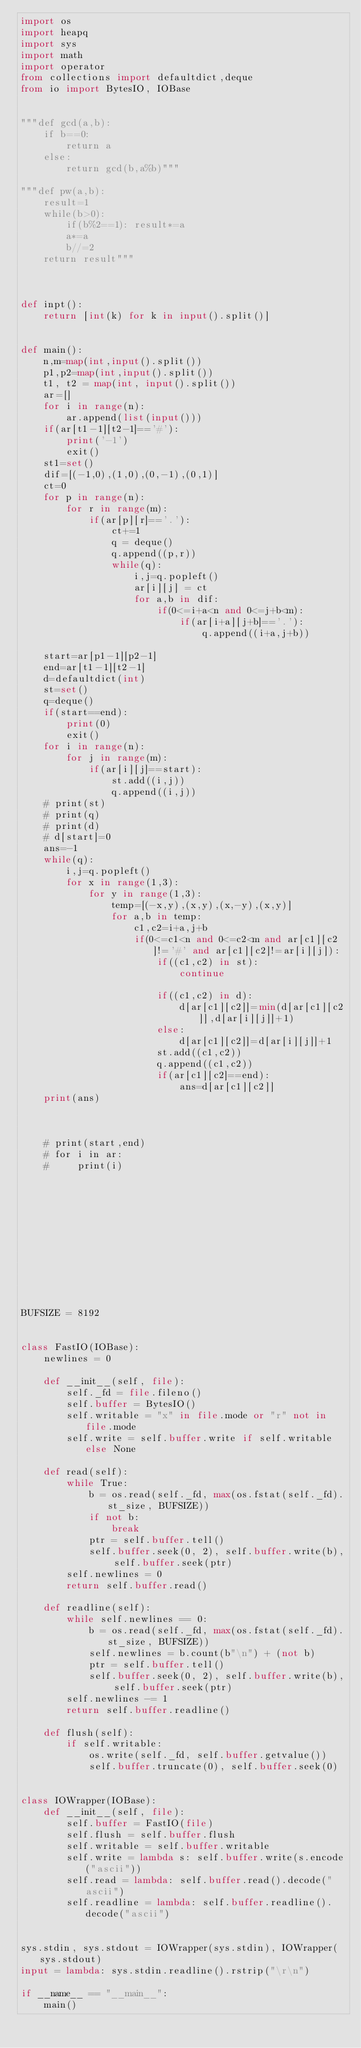<code> <loc_0><loc_0><loc_500><loc_500><_Python_>import os
import heapq
import sys
import math
import operator
from collections import defaultdict,deque
from io import BytesIO, IOBase


"""def gcd(a,b):
    if b==0:
        return a
    else:
        return gcd(b,a%b)"""

"""def pw(a,b):
    result=1
    while(b>0):
        if(b%2==1): result*=a
        a*=a
        b//=2
    return result"""



def inpt():
    return [int(k) for k in input().split()]


def main():
    n,m=map(int,input().split())
    p1,p2=map(int,input().split())
    t1, t2 = map(int, input().split())
    ar=[]
    for i in range(n):
        ar.append(list(input()))
    if(ar[t1-1][t2-1]=='#'):
        print('-1')
        exit()
    st1=set()
    dif=[(-1,0),(1,0),(0,-1),(0,1)]
    ct=0
    for p in range(n):
        for r in range(m):
            if(ar[p][r]=='.'):
                ct+=1
                q = deque()
                q.append((p,r))
                while(q):
                    i,j=q.popleft()
                    ar[i][j] = ct
                    for a,b in dif:
                        if(0<=i+a<n and 0<=j+b<m):
                            if(ar[i+a][j+b]=='.'):
                                q.append((i+a,j+b))

    start=ar[p1-1][p2-1]
    end=ar[t1-1][t2-1]
    d=defaultdict(int)
    st=set()
    q=deque()
    if(start==end):
        print(0)
        exit()
    for i in range(n):
        for j in range(m):
            if(ar[i][j]==start):
                st.add((i,j))
                q.append((i,j))
    # print(st)
    # print(q)
    # print(d)
    # d[start]=0
    ans=-1
    while(q):
        i,j=q.popleft()
        for x in range(1,3):
            for y in range(1,3):
                temp=[(-x,y),(x,y),(x,-y),(x,y)]
                for a,b in temp:
                    c1,c2=i+a,j+b
                    if(0<=c1<n and 0<=c2<m and ar[c1][c2]!='#' and ar[c1][c2]!=ar[i][j]):
                        if((c1,c2) in st):
                            continue

                        if((c1,c2) in d):
                            d[ar[c1][c2]]=min(d[ar[c1][c2]],d[ar[i][j]]+1)
                        else:
                            d[ar[c1][c2]]=d[ar[i][j]]+1
                        st.add((c1,c2))
                        q.append((c1,c2))
                        if(ar[c1][c2]==end):
                            ans=d[ar[c1][c2]]
    print(ans)



    # print(start,end)
    # for i in ar:
    #     print(i)












BUFSIZE = 8192


class FastIO(IOBase):
    newlines = 0

    def __init__(self, file):
        self._fd = file.fileno()
        self.buffer = BytesIO()
        self.writable = "x" in file.mode or "r" not in file.mode
        self.write = self.buffer.write if self.writable else None

    def read(self):
        while True:
            b = os.read(self._fd, max(os.fstat(self._fd).st_size, BUFSIZE))
            if not b:
                break
            ptr = self.buffer.tell()
            self.buffer.seek(0, 2), self.buffer.write(b), self.buffer.seek(ptr)
        self.newlines = 0
        return self.buffer.read()

    def readline(self):
        while self.newlines == 0:
            b = os.read(self._fd, max(os.fstat(self._fd).st_size, BUFSIZE))
            self.newlines = b.count(b"\n") + (not b)
            ptr = self.buffer.tell()
            self.buffer.seek(0, 2), self.buffer.write(b), self.buffer.seek(ptr)
        self.newlines -= 1
        return self.buffer.readline()

    def flush(self):
        if self.writable:
            os.write(self._fd, self.buffer.getvalue())
            self.buffer.truncate(0), self.buffer.seek(0)


class IOWrapper(IOBase):
    def __init__(self, file):
        self.buffer = FastIO(file)
        self.flush = self.buffer.flush
        self.writable = self.buffer.writable
        self.write = lambda s: self.buffer.write(s.encode("ascii"))
        self.read = lambda: self.buffer.read().decode("ascii")
        self.readline = lambda: self.buffer.readline().decode("ascii")


sys.stdin, sys.stdout = IOWrapper(sys.stdin), IOWrapper(sys.stdout)
input = lambda: sys.stdin.readline().rstrip("\r\n")

if __name__ == "__main__":
    main()
</code> 